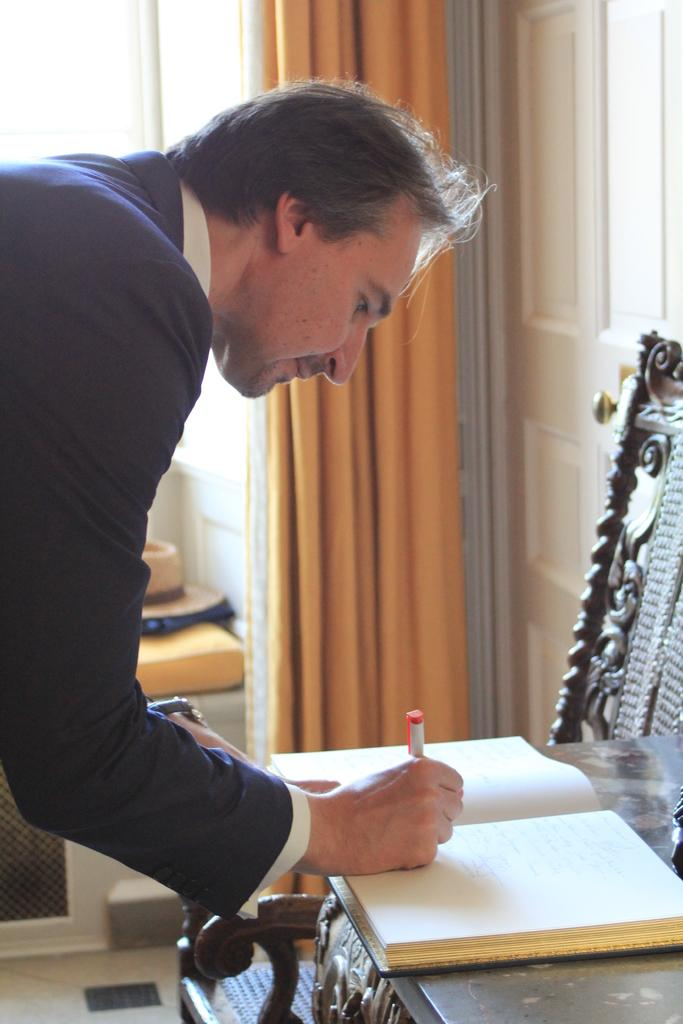Who is the person in the image? There is a man in the image. What is the man doing in the image? The man is writing in a book. Where is the book located in the image? The book is on a table. What can be seen in the background of the image? There is a curtain beside a door in the background. What piece of furniture is beside the table? There is a chair beside the table. What type of bun is visible on the man's head in the image? There is no bun visible on the man's head in the image. What is the condition of the sky in the image? There is no sky visible in the image, as it is an indoor scene. 